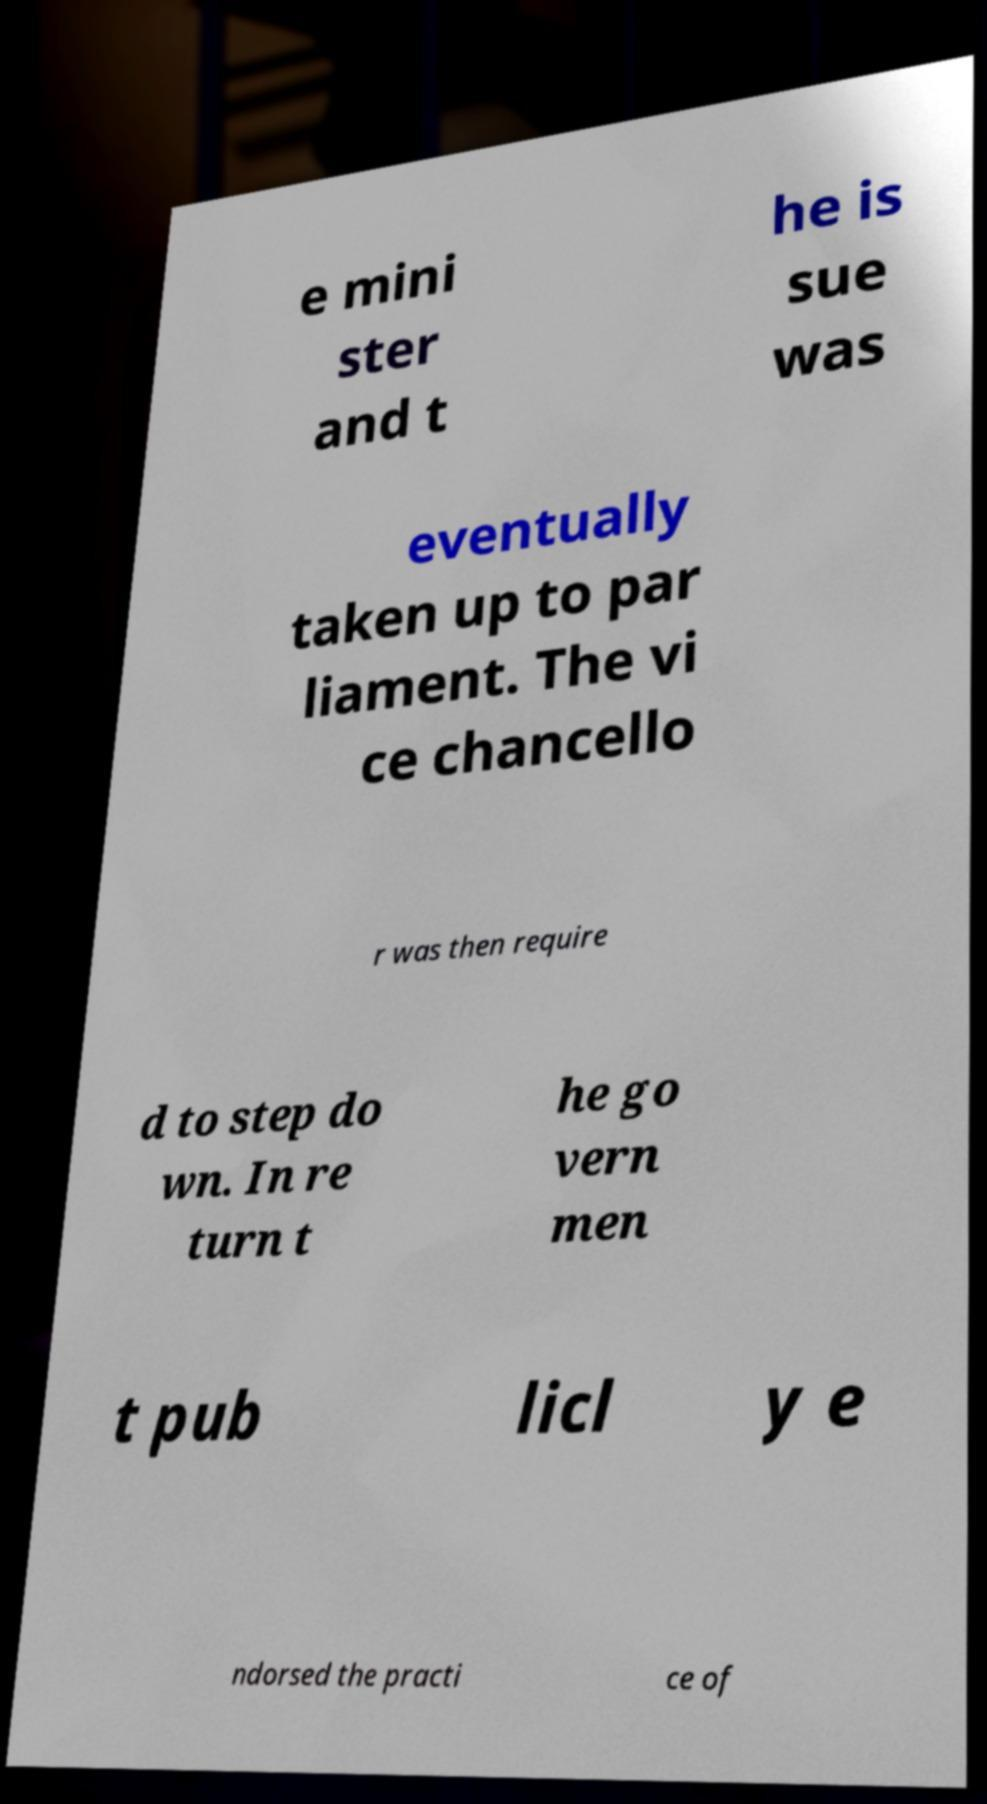For documentation purposes, I need the text within this image transcribed. Could you provide that? e mini ster and t he is sue was eventually taken up to par liament. The vi ce chancello r was then require d to step do wn. In re turn t he go vern men t pub licl y e ndorsed the practi ce of 